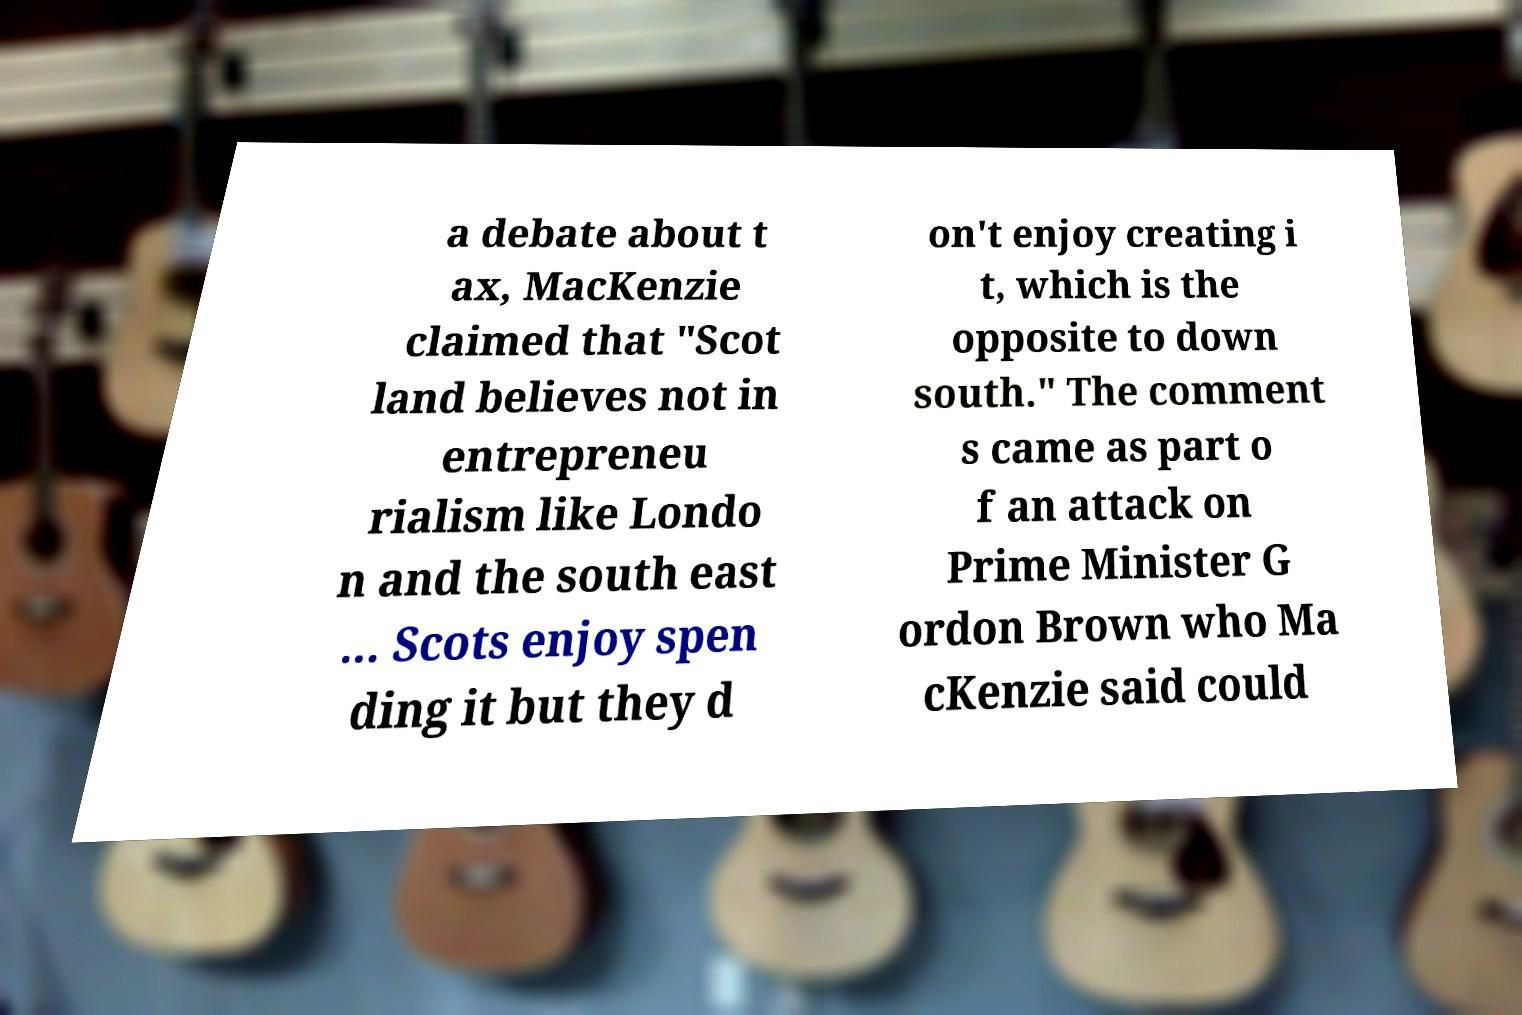Can you accurately transcribe the text from the provided image for me? a debate about t ax, MacKenzie claimed that "Scot land believes not in entrepreneu rialism like Londo n and the south east ... Scots enjoy spen ding it but they d on't enjoy creating i t, which is the opposite to down south." The comment s came as part o f an attack on Prime Minister G ordon Brown who Ma cKenzie said could 